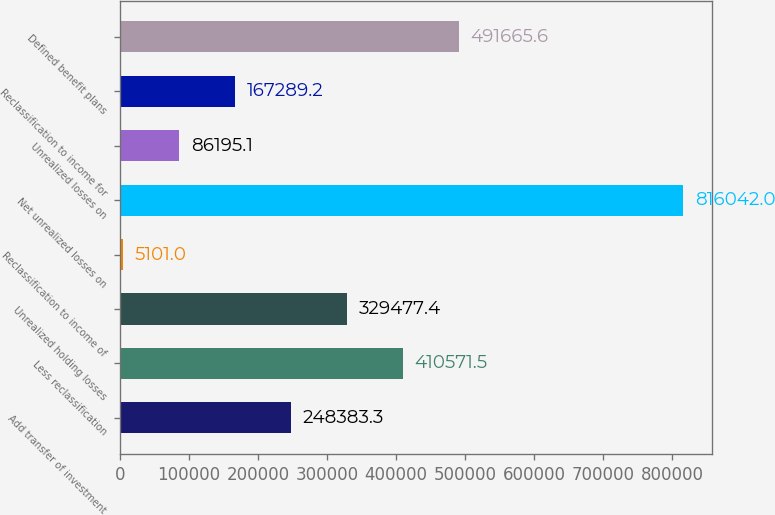<chart> <loc_0><loc_0><loc_500><loc_500><bar_chart><fcel>Add transfer of investment<fcel>Less reclassification<fcel>Unrealized holding losses<fcel>Reclassification to income of<fcel>Net unrealized losses on<fcel>Unrealized losses on<fcel>Reclassification to income for<fcel>Defined benefit plans<nl><fcel>248383<fcel>410572<fcel>329477<fcel>5101<fcel>816042<fcel>86195.1<fcel>167289<fcel>491666<nl></chart> 